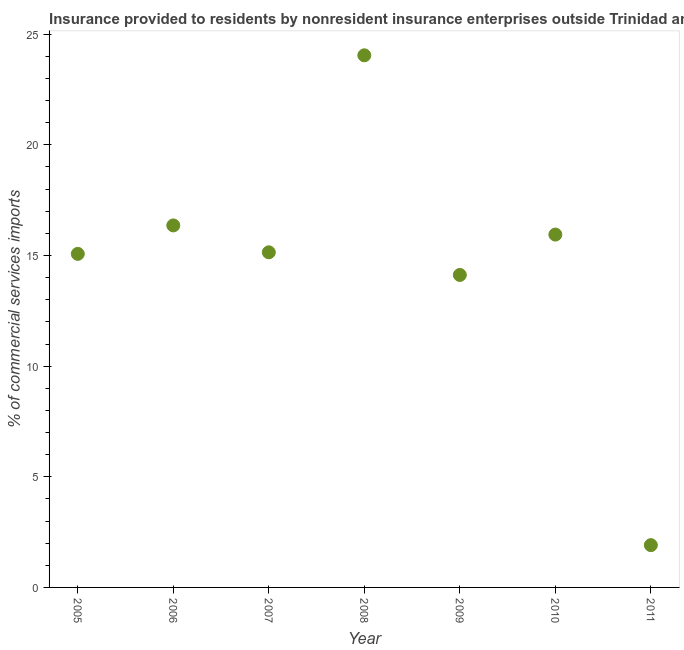What is the insurance provided by non-residents in 2006?
Provide a short and direct response. 16.36. Across all years, what is the maximum insurance provided by non-residents?
Provide a succinct answer. 24.05. Across all years, what is the minimum insurance provided by non-residents?
Ensure brevity in your answer.  1.91. What is the sum of the insurance provided by non-residents?
Give a very brief answer. 102.6. What is the difference between the insurance provided by non-residents in 2006 and 2011?
Your response must be concise. 14.45. What is the average insurance provided by non-residents per year?
Offer a terse response. 14.66. What is the median insurance provided by non-residents?
Your response must be concise. 15.14. In how many years, is the insurance provided by non-residents greater than 5 %?
Provide a short and direct response. 6. Do a majority of the years between 2006 and 2010 (inclusive) have insurance provided by non-residents greater than 15 %?
Give a very brief answer. Yes. What is the ratio of the insurance provided by non-residents in 2007 to that in 2011?
Give a very brief answer. 7.92. Is the insurance provided by non-residents in 2008 less than that in 2010?
Keep it short and to the point. No. What is the difference between the highest and the second highest insurance provided by non-residents?
Give a very brief answer. 7.69. Is the sum of the insurance provided by non-residents in 2006 and 2008 greater than the maximum insurance provided by non-residents across all years?
Provide a short and direct response. Yes. What is the difference between the highest and the lowest insurance provided by non-residents?
Your answer should be compact. 22.14. Does the insurance provided by non-residents monotonically increase over the years?
Make the answer very short. No. How many dotlines are there?
Provide a succinct answer. 1. How many years are there in the graph?
Your response must be concise. 7. What is the difference between two consecutive major ticks on the Y-axis?
Your answer should be compact. 5. Does the graph contain any zero values?
Your answer should be very brief. No. Does the graph contain grids?
Ensure brevity in your answer.  No. What is the title of the graph?
Offer a terse response. Insurance provided to residents by nonresident insurance enterprises outside Trinidad and Tobago. What is the label or title of the Y-axis?
Make the answer very short. % of commercial services imports. What is the % of commercial services imports in 2005?
Your answer should be very brief. 15.07. What is the % of commercial services imports in 2006?
Offer a very short reply. 16.36. What is the % of commercial services imports in 2007?
Give a very brief answer. 15.14. What is the % of commercial services imports in 2008?
Offer a very short reply. 24.05. What is the % of commercial services imports in 2009?
Your response must be concise. 14.12. What is the % of commercial services imports in 2010?
Your answer should be very brief. 15.95. What is the % of commercial services imports in 2011?
Provide a short and direct response. 1.91. What is the difference between the % of commercial services imports in 2005 and 2006?
Your response must be concise. -1.29. What is the difference between the % of commercial services imports in 2005 and 2007?
Your response must be concise. -0.07. What is the difference between the % of commercial services imports in 2005 and 2008?
Offer a very short reply. -8.97. What is the difference between the % of commercial services imports in 2005 and 2009?
Offer a terse response. 0.95. What is the difference between the % of commercial services imports in 2005 and 2010?
Your response must be concise. -0.87. What is the difference between the % of commercial services imports in 2005 and 2011?
Ensure brevity in your answer.  13.16. What is the difference between the % of commercial services imports in 2006 and 2007?
Offer a terse response. 1.22. What is the difference between the % of commercial services imports in 2006 and 2008?
Keep it short and to the point. -7.69. What is the difference between the % of commercial services imports in 2006 and 2009?
Your answer should be compact. 2.24. What is the difference between the % of commercial services imports in 2006 and 2010?
Offer a very short reply. 0.41. What is the difference between the % of commercial services imports in 2006 and 2011?
Offer a very short reply. 14.45. What is the difference between the % of commercial services imports in 2007 and 2008?
Give a very brief answer. -8.9. What is the difference between the % of commercial services imports in 2007 and 2009?
Provide a succinct answer. 1.02. What is the difference between the % of commercial services imports in 2007 and 2010?
Provide a short and direct response. -0.8. What is the difference between the % of commercial services imports in 2007 and 2011?
Provide a succinct answer. 13.23. What is the difference between the % of commercial services imports in 2008 and 2009?
Keep it short and to the point. 9.93. What is the difference between the % of commercial services imports in 2008 and 2010?
Keep it short and to the point. 8.1. What is the difference between the % of commercial services imports in 2008 and 2011?
Provide a succinct answer. 22.14. What is the difference between the % of commercial services imports in 2009 and 2010?
Keep it short and to the point. -1.82. What is the difference between the % of commercial services imports in 2009 and 2011?
Give a very brief answer. 12.21. What is the difference between the % of commercial services imports in 2010 and 2011?
Provide a succinct answer. 14.03. What is the ratio of the % of commercial services imports in 2005 to that in 2006?
Keep it short and to the point. 0.92. What is the ratio of the % of commercial services imports in 2005 to that in 2008?
Your answer should be very brief. 0.63. What is the ratio of the % of commercial services imports in 2005 to that in 2009?
Ensure brevity in your answer.  1.07. What is the ratio of the % of commercial services imports in 2005 to that in 2010?
Your answer should be compact. 0.94. What is the ratio of the % of commercial services imports in 2005 to that in 2011?
Provide a succinct answer. 7.89. What is the ratio of the % of commercial services imports in 2006 to that in 2008?
Provide a succinct answer. 0.68. What is the ratio of the % of commercial services imports in 2006 to that in 2009?
Keep it short and to the point. 1.16. What is the ratio of the % of commercial services imports in 2006 to that in 2011?
Make the answer very short. 8.56. What is the ratio of the % of commercial services imports in 2007 to that in 2008?
Give a very brief answer. 0.63. What is the ratio of the % of commercial services imports in 2007 to that in 2009?
Give a very brief answer. 1.07. What is the ratio of the % of commercial services imports in 2007 to that in 2011?
Your response must be concise. 7.92. What is the ratio of the % of commercial services imports in 2008 to that in 2009?
Your answer should be compact. 1.7. What is the ratio of the % of commercial services imports in 2008 to that in 2010?
Provide a short and direct response. 1.51. What is the ratio of the % of commercial services imports in 2008 to that in 2011?
Your answer should be very brief. 12.58. What is the ratio of the % of commercial services imports in 2009 to that in 2010?
Ensure brevity in your answer.  0.89. What is the ratio of the % of commercial services imports in 2009 to that in 2011?
Your answer should be very brief. 7.39. What is the ratio of the % of commercial services imports in 2010 to that in 2011?
Your answer should be very brief. 8.34. 